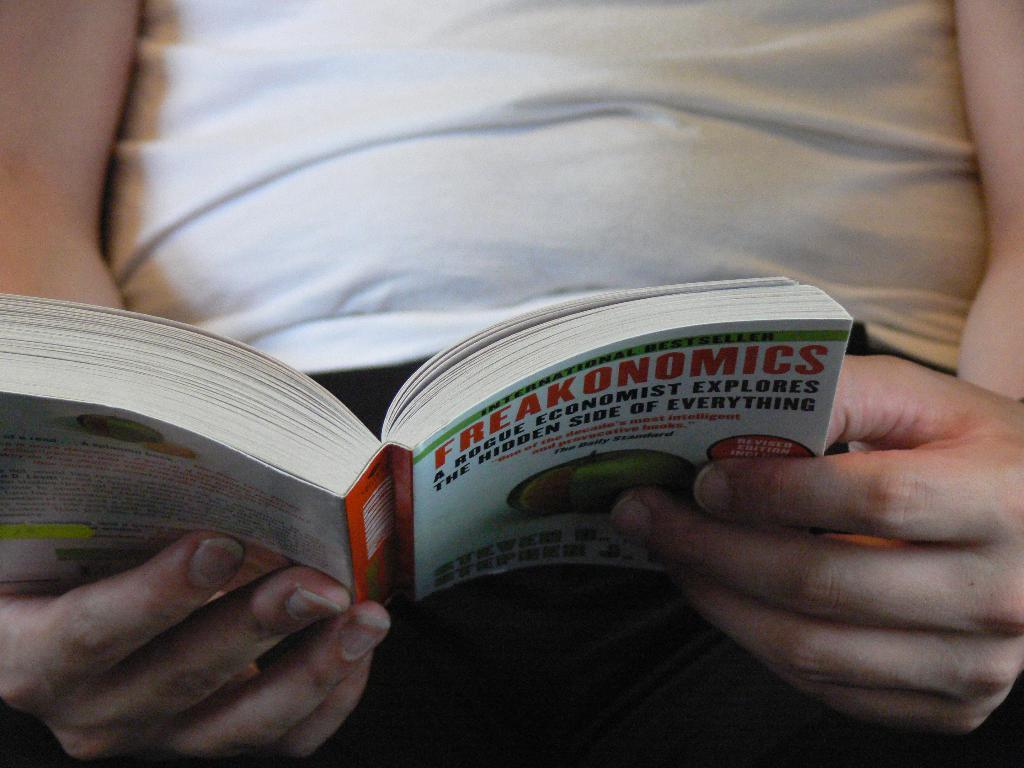<image>
Give a short and clear explanation of the subsequent image. The person is reading the book called Freakonomics 